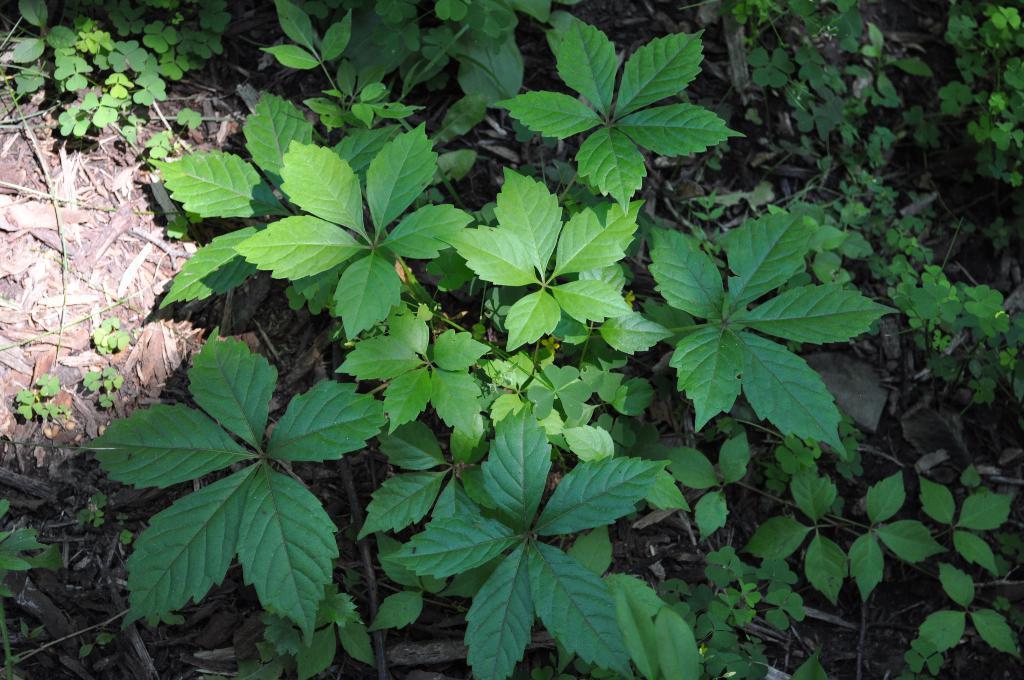Could you give a brief overview of what you see in this image? In this picture there are plants. 